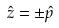Convert formula to latex. <formula><loc_0><loc_0><loc_500><loc_500>\hat { z } = \pm \hat { p }</formula> 